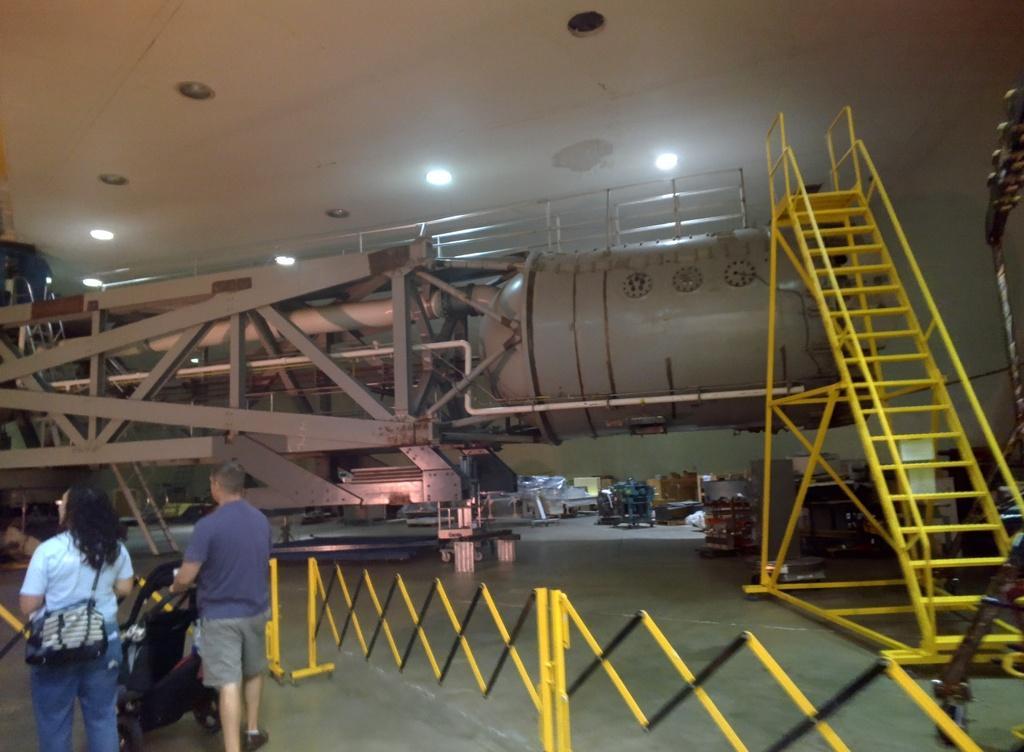Please provide a concise description of this image. This is an inside view. Here I can see a metal object which is looking like a machine. On the left side there are some metal rods. On the right side, I can see the stairs. At the bottom of the image there is fencing. On the left side, I can see a woman and a men are walking on the floor. The man is holding a wheelchair. At the top I can see the lights. 